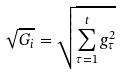Convert formula to latex. <formula><loc_0><loc_0><loc_500><loc_500>\sqrt { G _ { i } } = \sqrt { \sum _ { \tau = 1 } ^ { t } g _ { \tau } ^ { 2 } }</formula> 